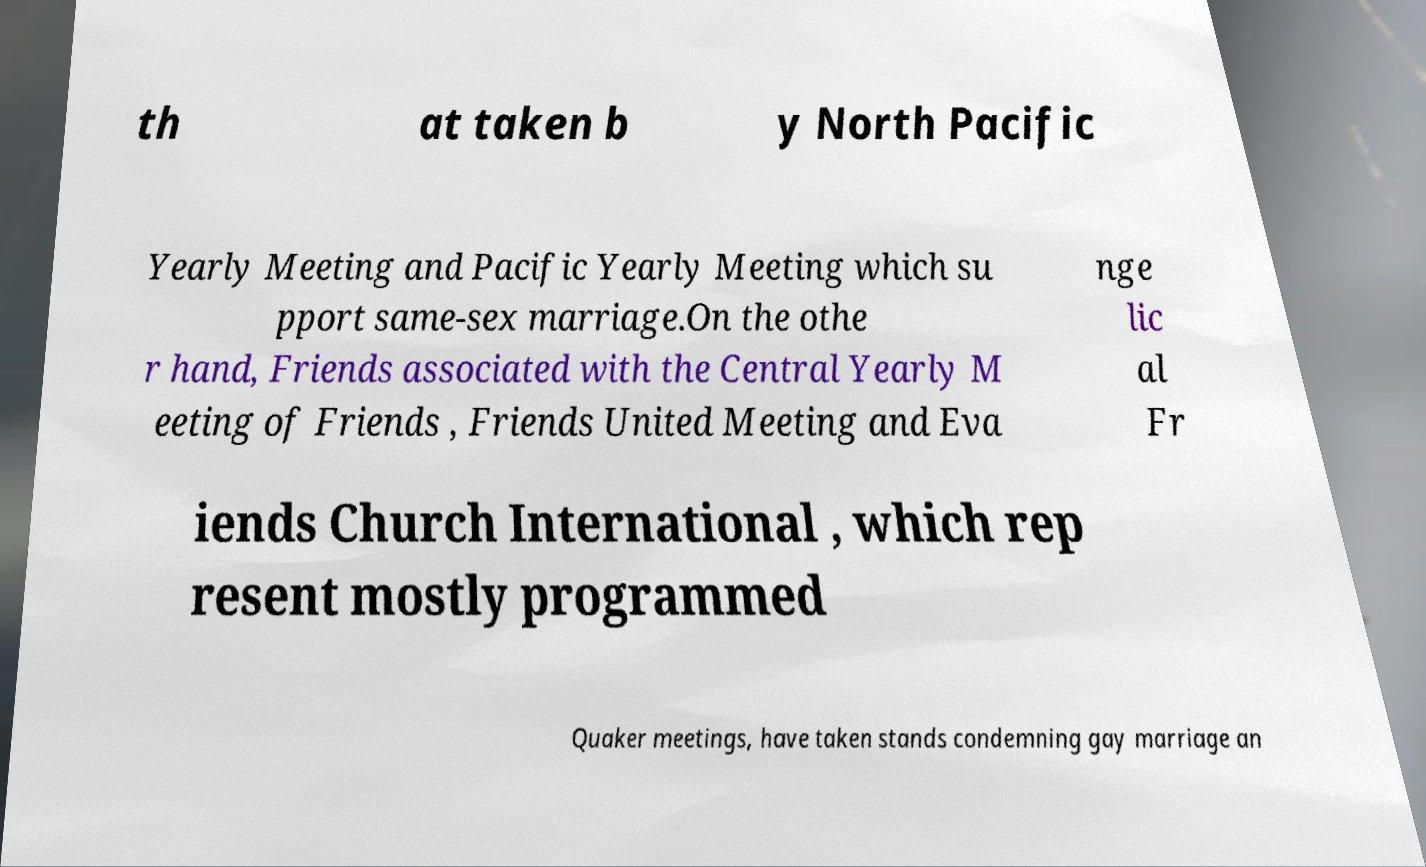Could you extract and type out the text from this image? th at taken b y North Pacific Yearly Meeting and Pacific Yearly Meeting which su pport same-sex marriage.On the othe r hand, Friends associated with the Central Yearly M eeting of Friends , Friends United Meeting and Eva nge lic al Fr iends Church International , which rep resent mostly programmed Quaker meetings, have taken stands condemning gay marriage an 